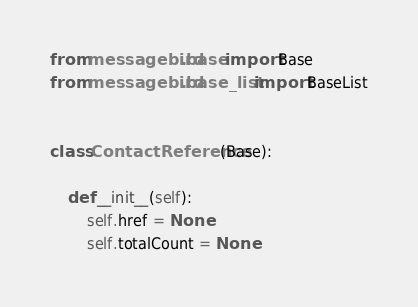Convert code to text. <code><loc_0><loc_0><loc_500><loc_500><_Python_>from messagebird.base import Base
from messagebird.base_list import BaseList


class ContactReference(Base):

    def __init__(self):
        self.href = None
        self.totalCount = None

</code> 